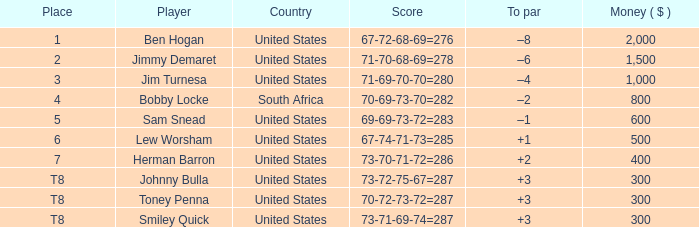What is the to par of the player with a score of 73-70-71-72=286? 2.0. 